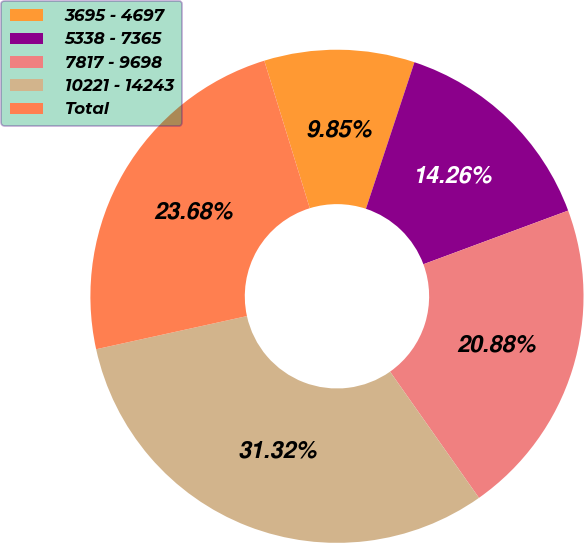Convert chart to OTSL. <chart><loc_0><loc_0><loc_500><loc_500><pie_chart><fcel>3695 - 4697<fcel>5338 - 7365<fcel>7817 - 9698<fcel>10221 - 14243<fcel>Total<nl><fcel>9.85%<fcel>14.26%<fcel>20.88%<fcel>31.32%<fcel>23.68%<nl></chart> 